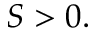Convert formula to latex. <formula><loc_0><loc_0><loc_500><loc_500>S > 0 .</formula> 